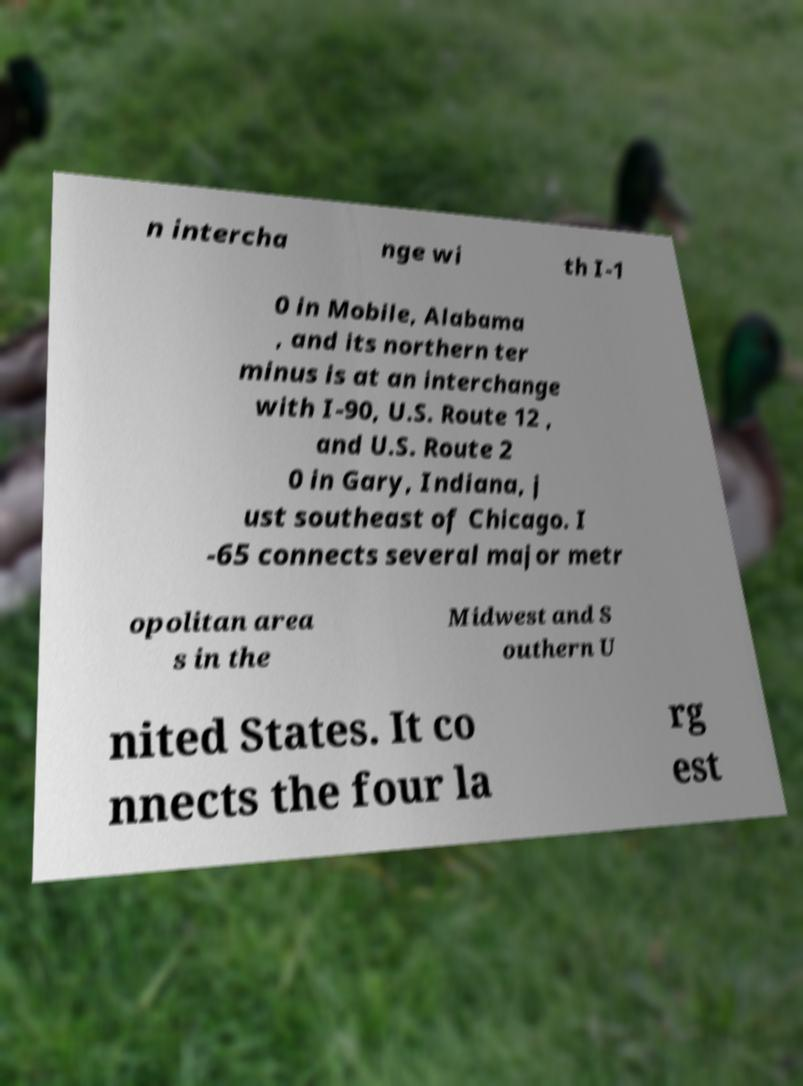Can you read and provide the text displayed in the image?This photo seems to have some interesting text. Can you extract and type it out for me? n intercha nge wi th I-1 0 in Mobile, Alabama , and its northern ter minus is at an interchange with I-90, U.S. Route 12 , and U.S. Route 2 0 in Gary, Indiana, j ust southeast of Chicago. I -65 connects several major metr opolitan area s in the Midwest and S outhern U nited States. It co nnects the four la rg est 